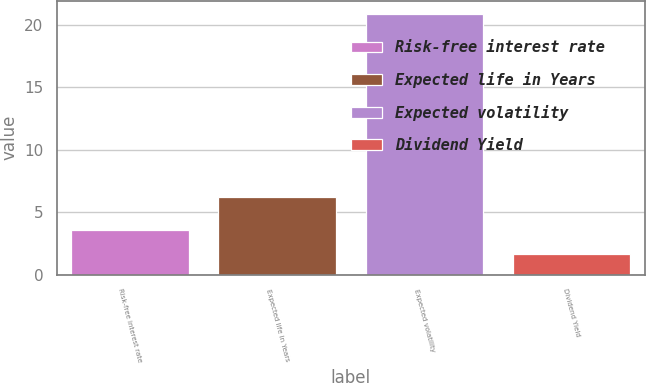<chart> <loc_0><loc_0><loc_500><loc_500><bar_chart><fcel>Risk-free interest rate<fcel>Expected life in Years<fcel>Expected volatility<fcel>Dividend Yield<nl><fcel>3.62<fcel>6.2<fcel>20.9<fcel>1.7<nl></chart> 